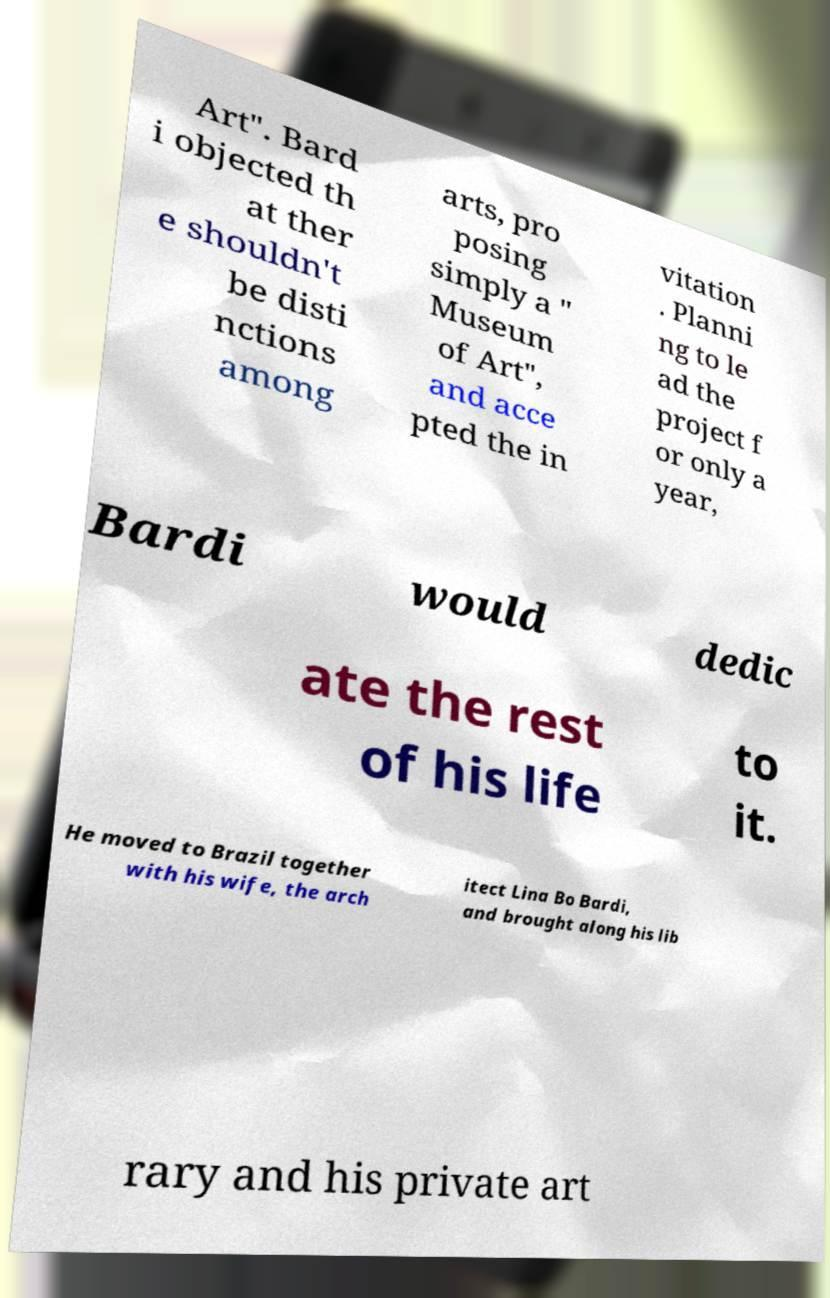Can you read and provide the text displayed in the image?This photo seems to have some interesting text. Can you extract and type it out for me? Art". Bard i objected th at ther e shouldn't be disti nctions among arts, pro posing simply a " Museum of Art", and acce pted the in vitation . Planni ng to le ad the project f or only a year, Bardi would dedic ate the rest of his life to it. He moved to Brazil together with his wife, the arch itect Lina Bo Bardi, and brought along his lib rary and his private art 